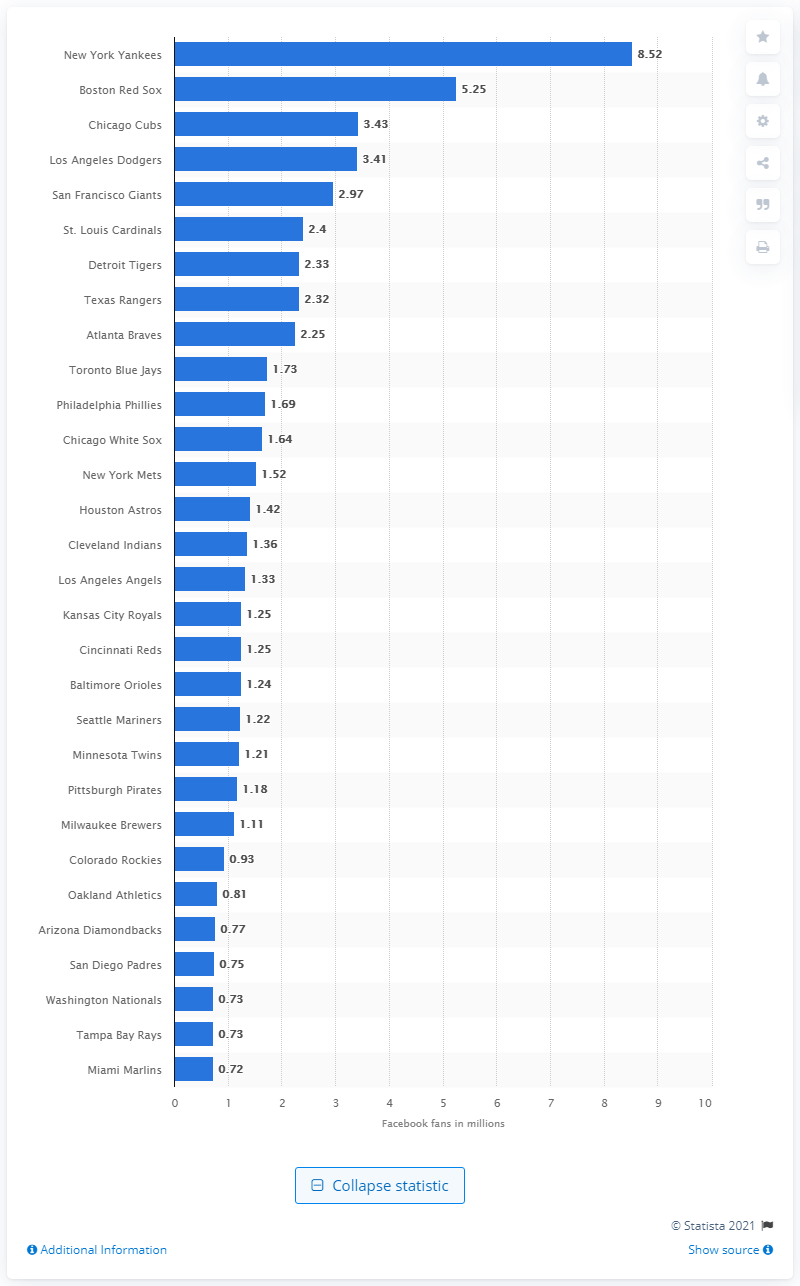Indicate a few pertinent items in this graphic. As of August 2020, the New York Yankees had approximately 8.52 million followers on Facebook. 